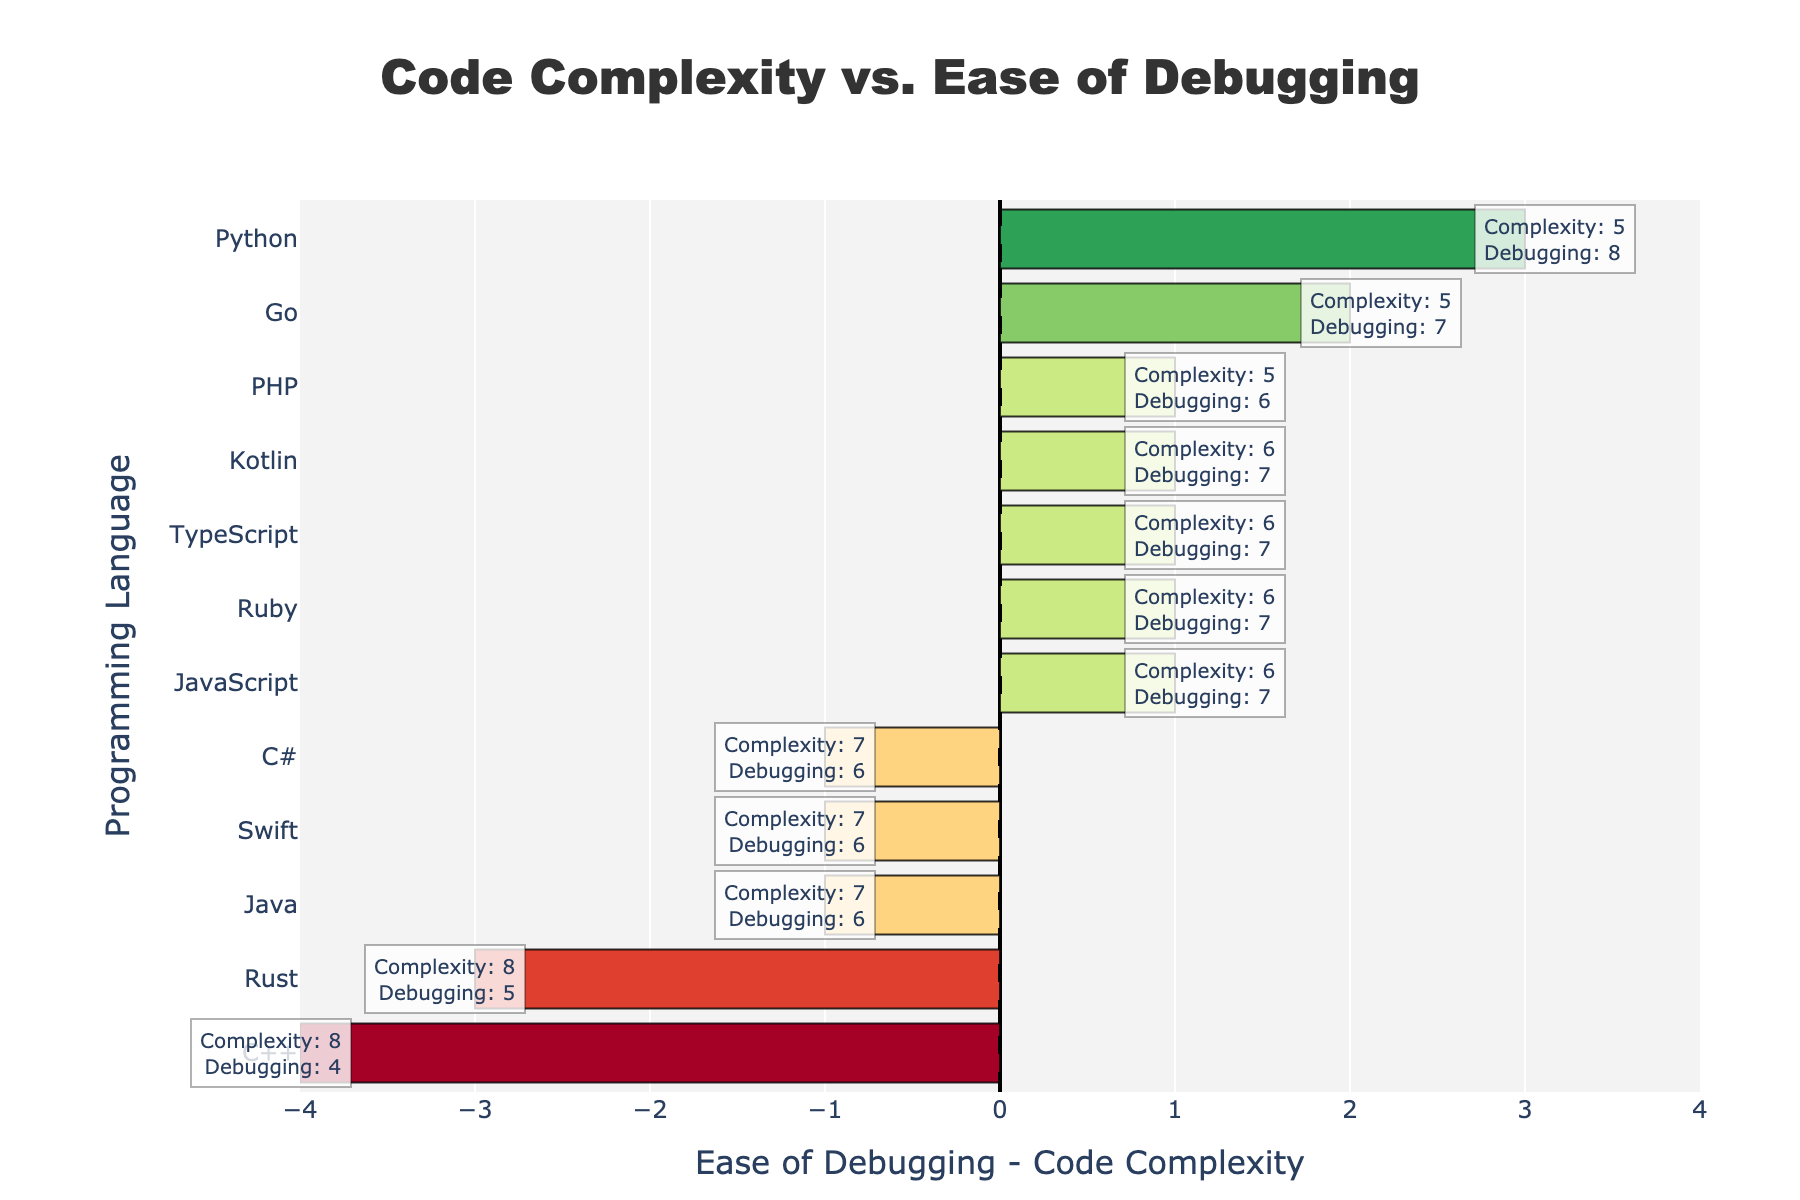What language has the most negative difference between Ease of Debugging and Code Complexity? The language with the most negative difference has the longest bar extending to the left. By examining the chart, C++ has the most significant negative difference.
Answer: C++ Which languages have a positive difference between Ease of Debugging and Code Complexity? A positive difference is represented by bars extending to the right. From the chart, the languages with positive differences are Python, PHP, JavaScript, Ruby, TypeScript, Go, and Kotlin.
Answer: Python, PHP, JavaScript, Ruby, TypeScript, Go, Kotlin Compare Java and C++ in terms of their Ease of Debugging and Code Complexity. Java and C++ can be compared by examining their respective positions in the chart. For Java, the Ease of Debugging is 6 and Code Complexity is 7. For C++, the Ease of Debugging is 4 and Code Complexity is 8. Java has a higher Ease of Debugging but also higher Code Complexity compared to C++.
Answer: Java: Ease of Debugging 6, Complexity 7; C++: Ease of Debugging 4, Complexity 8 What is the overall trend observed for Ease of Debugging compared to Code Complexity across all languages? Overall, by examining the orientation and length of the bars, it can be noted that more languages tend to lean towards a positive difference indicating Ease of Debugging often being higher or the same as Code Complexity.
Answer: Ease of Debugging is generally higher or the same as Code Complexity What language has the highest positive difference between Ease of Debugging and Code Complexity? The language with the highest positive difference has the longest bar extending to the right. From the chart, Python has the highest positive difference.
Answer: Python Is there any language where Code Complexity equals Ease of Debugging? If yes, which one? The language where Code Complexity equals Ease of Debugging will have a bar length of zero, centered at the origin. From the chart, none of the languages have a bar length of zero.
Answer: None How many languages have an Ease of Debugging greater than their Code Complexity by exactly 1? To determine this, look at the languages whose bars extend exactly one unit to the right of the origin. From the chart, the languages are JavaScript, Ruby, TypeScript, Go, and Kotlin.
Answer: Five languages Which language is closest to the central line (x=0)? The language closest to the central line represented by the shortest bar (whether positive or negative) is Kotlin.
Answer: Kotlin Which language shows the biggest gap in terms of Ease of Debugging vs. Code Complexity? The language with the biggest gap will have the longest bar, regardless of direction. From the chart, C++ has the longest bar, indicating the biggest gap.
Answer: C++ What is the range of differences observed in the plot? The range can be found by taking the maximum positive difference and the maximum negative difference in the chart. The maximum positive difference is +3 (Python), and the maximum negative difference is -4 (C++), giving a range of -4 to +3.
Answer: -4 to +3 